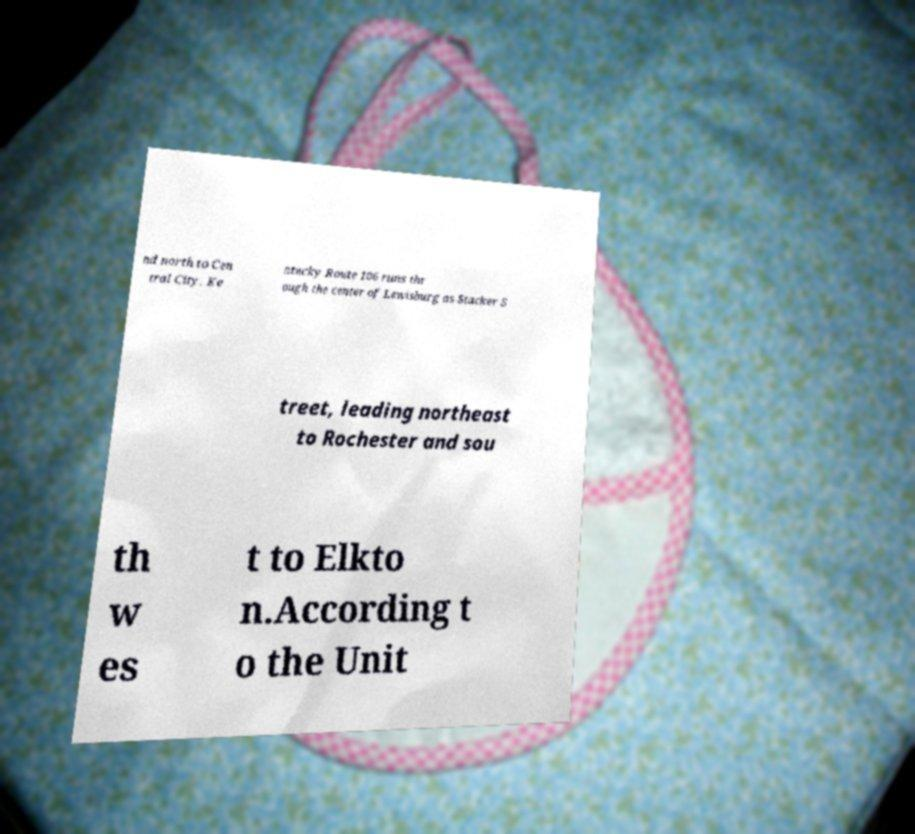What messages or text are displayed in this image? I need them in a readable, typed format. nd north to Cen tral City. Ke ntucky Route 106 runs thr ough the center of Lewisburg as Stacker S treet, leading northeast to Rochester and sou th w es t to Elkto n.According t o the Unit 